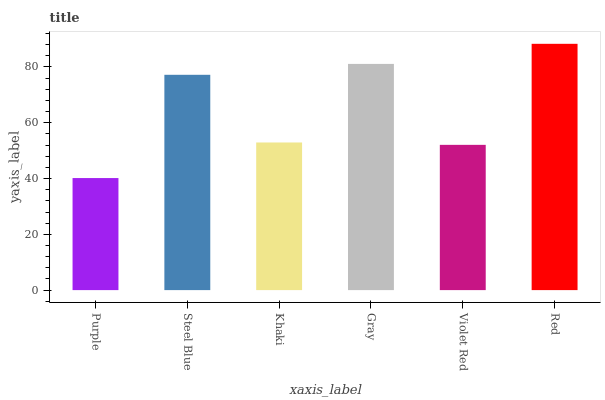Is Purple the minimum?
Answer yes or no. Yes. Is Red the maximum?
Answer yes or no. Yes. Is Steel Blue the minimum?
Answer yes or no. No. Is Steel Blue the maximum?
Answer yes or no. No. Is Steel Blue greater than Purple?
Answer yes or no. Yes. Is Purple less than Steel Blue?
Answer yes or no. Yes. Is Purple greater than Steel Blue?
Answer yes or no. No. Is Steel Blue less than Purple?
Answer yes or no. No. Is Steel Blue the high median?
Answer yes or no. Yes. Is Khaki the low median?
Answer yes or no. Yes. Is Violet Red the high median?
Answer yes or no. No. Is Gray the low median?
Answer yes or no. No. 